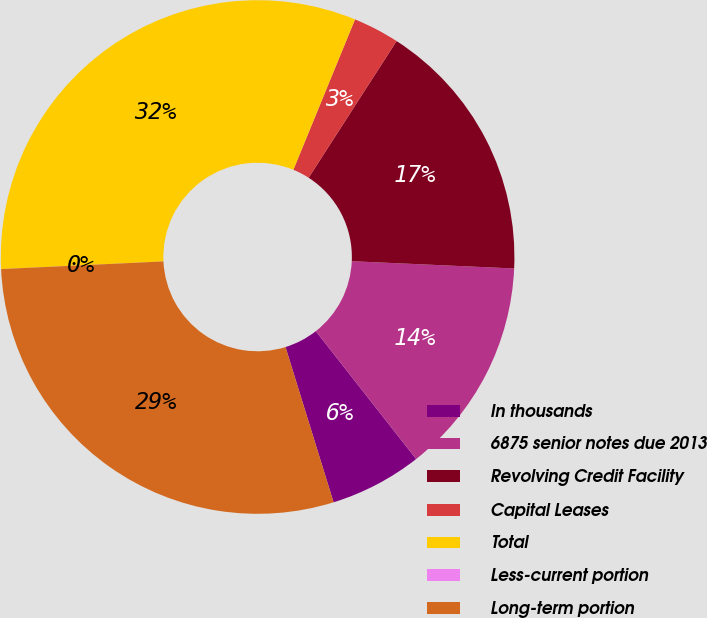<chart> <loc_0><loc_0><loc_500><loc_500><pie_chart><fcel>In thousands<fcel>6875 senior notes due 2013<fcel>Revolving Credit Facility<fcel>Capital Leases<fcel>Total<fcel>Less-current portion<fcel>Long-term portion<nl><fcel>5.81%<fcel>13.7%<fcel>16.61%<fcel>2.91%<fcel>31.94%<fcel>0.0%<fcel>29.03%<nl></chart> 